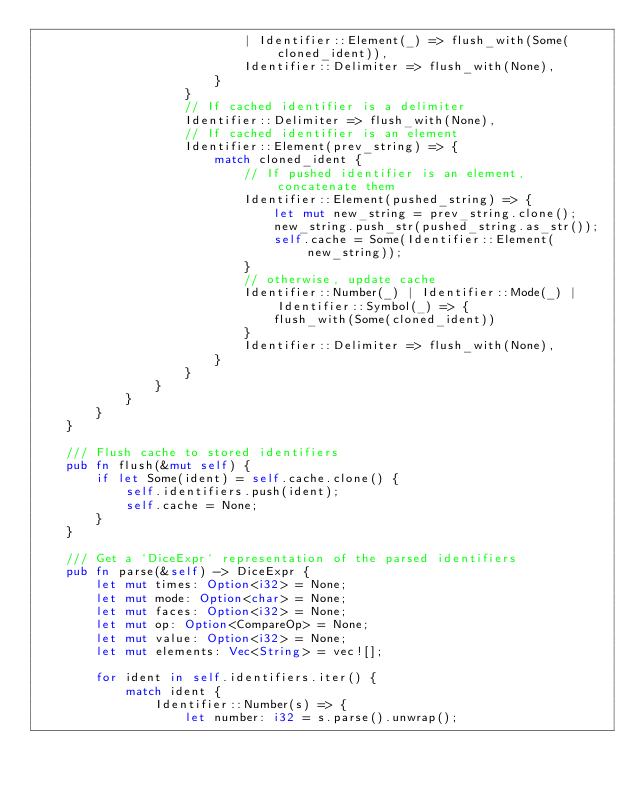Convert code to text. <code><loc_0><loc_0><loc_500><loc_500><_Rust_>                            | Identifier::Element(_) => flush_with(Some(cloned_ident)),
                            Identifier::Delimiter => flush_with(None),
                        }
                    }
                    // If cached identifier is a delimiter
                    Identifier::Delimiter => flush_with(None),
                    // If cached identifier is an element
                    Identifier::Element(prev_string) => {
                        match cloned_ident {
                            // If pushed identifier is an element, concatenate them
                            Identifier::Element(pushed_string) => {
                                let mut new_string = prev_string.clone();
                                new_string.push_str(pushed_string.as_str());
                                self.cache = Some(Identifier::Element(new_string));
                            }
                            // otherwise, update cache
                            Identifier::Number(_) | Identifier::Mode(_) | Identifier::Symbol(_) => {
                                flush_with(Some(cloned_ident))
                            }
                            Identifier::Delimiter => flush_with(None),
                        }
                    }
                }
            }
        }
    }

    /// Flush cache to stored identifiers
    pub fn flush(&mut self) {
        if let Some(ident) = self.cache.clone() {
            self.identifiers.push(ident);
            self.cache = None;
        }
    }

    /// Get a `DiceExpr` representation of the parsed identifiers
    pub fn parse(&self) -> DiceExpr {
        let mut times: Option<i32> = None;
        let mut mode: Option<char> = None;
        let mut faces: Option<i32> = None;
        let mut op: Option<CompareOp> = None;
        let mut value: Option<i32> = None;
        let mut elements: Vec<String> = vec![];

        for ident in self.identifiers.iter() {
            match ident {
                Identifier::Number(s) => {
                    let number: i32 = s.parse().unwrap();</code> 